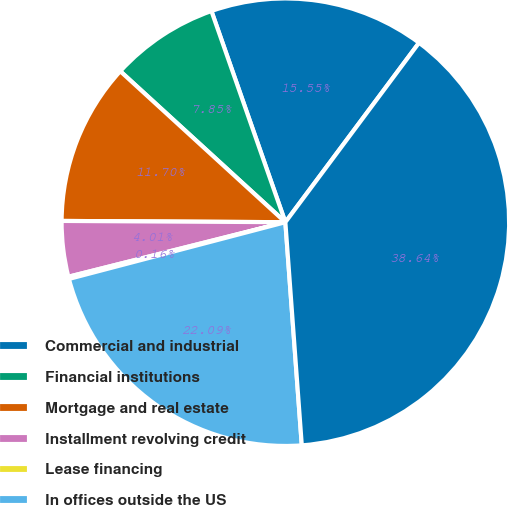Convert chart to OTSL. <chart><loc_0><loc_0><loc_500><loc_500><pie_chart><fcel>Commercial and industrial<fcel>Financial institutions<fcel>Mortgage and real estate<fcel>Installment revolving credit<fcel>Lease financing<fcel>In offices outside the US<fcel>Total corporate loans<nl><fcel>15.55%<fcel>7.85%<fcel>11.7%<fcel>4.01%<fcel>0.16%<fcel>22.09%<fcel>38.64%<nl></chart> 